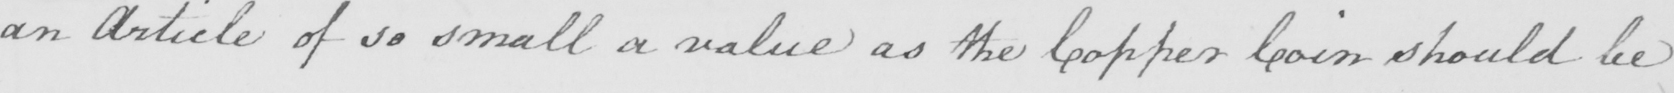Can you read and transcribe this handwriting? an Article of so small a value as the Copper Coin should be 